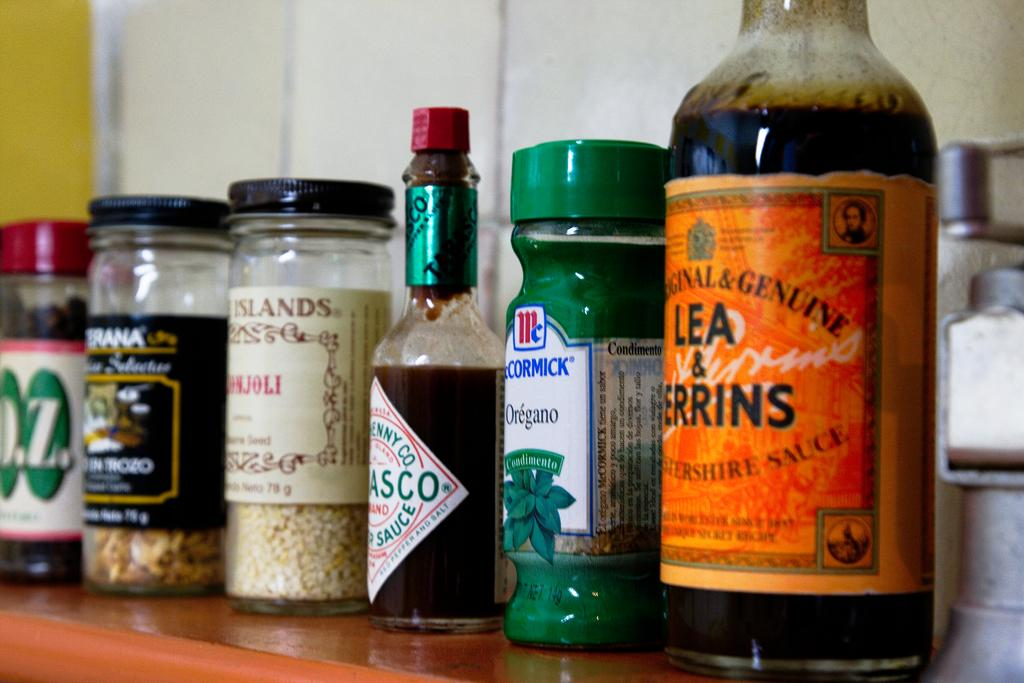<image>
Summarize the visual content of the image. A row of spices and condiments including Oregano and Tabasco. 